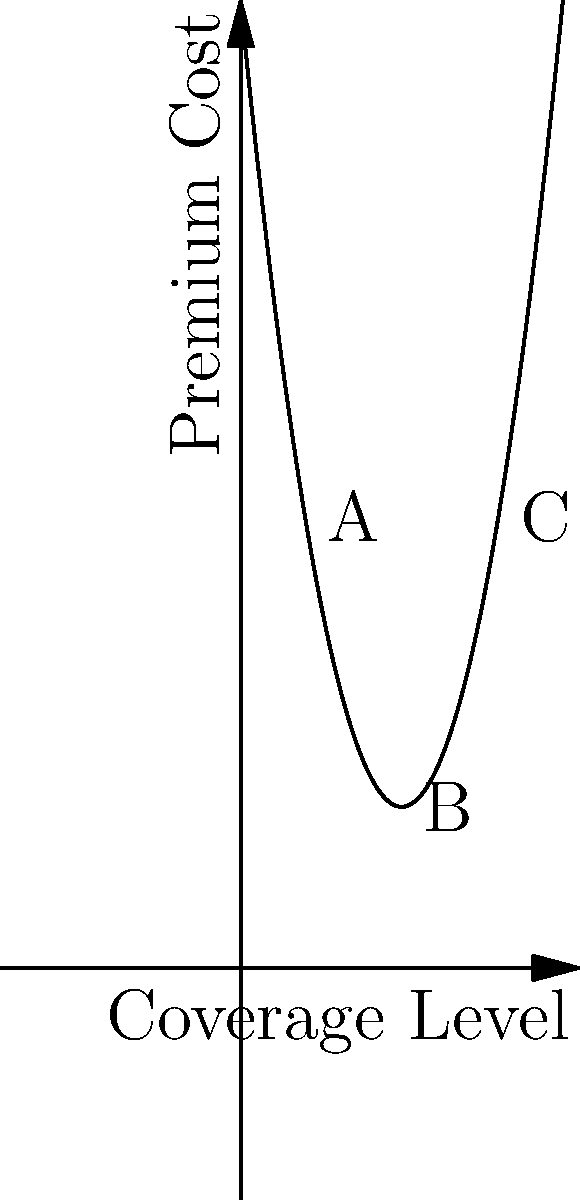The graph shows the relationship between insurance coverage levels and premium costs for a typical health insurance plan. Point A represents basic coverage, B represents moderate coverage, and C represents comprehensive coverage. If this trend continues, what level of coverage would minimize premium costs for consumers, and how might this impact access to healthcare? To solve this problem, we need to analyze the quadratic function represented by the graph:

1. The graph is a parabola opening upward, indicating a quadratic function in the form $f(x) = ax^2 + bx + c$, where $a > 0$.

2. The vertex of the parabola represents the minimum point of the function, which is the coverage level that minimizes premium costs.

3. To find the vertex, we can use the formula $x = -\frac{b}{2a}$, where $a$ and $b$ are coefficients of the quadratic function.

4. Without exact values, we can estimate the vertex to be around 50% coverage level.

5. This means that premiums are lowest at a moderate level of coverage (around 50%).

6. Impact on healthcare access:
   - Lower coverage levels (below 50%) might have higher premiums, discouraging basic insurance adoption.
   - Higher coverage levels (above 50%) also have higher premiums, potentially making comprehensive coverage unaffordable for many.
   - The system incentivizes moderate coverage, which may leave gaps in healthcare access for more extensive or specialized treatments.

7. From an activist perspective, this model demonstrates how business-friendly regulations can create a system where both low and high levels of coverage are financially punitive, potentially leaving many people underinsured or with inadequate coverage for their health needs.
Answer: 50% coverage minimizes costs; limits access to comprehensive care 